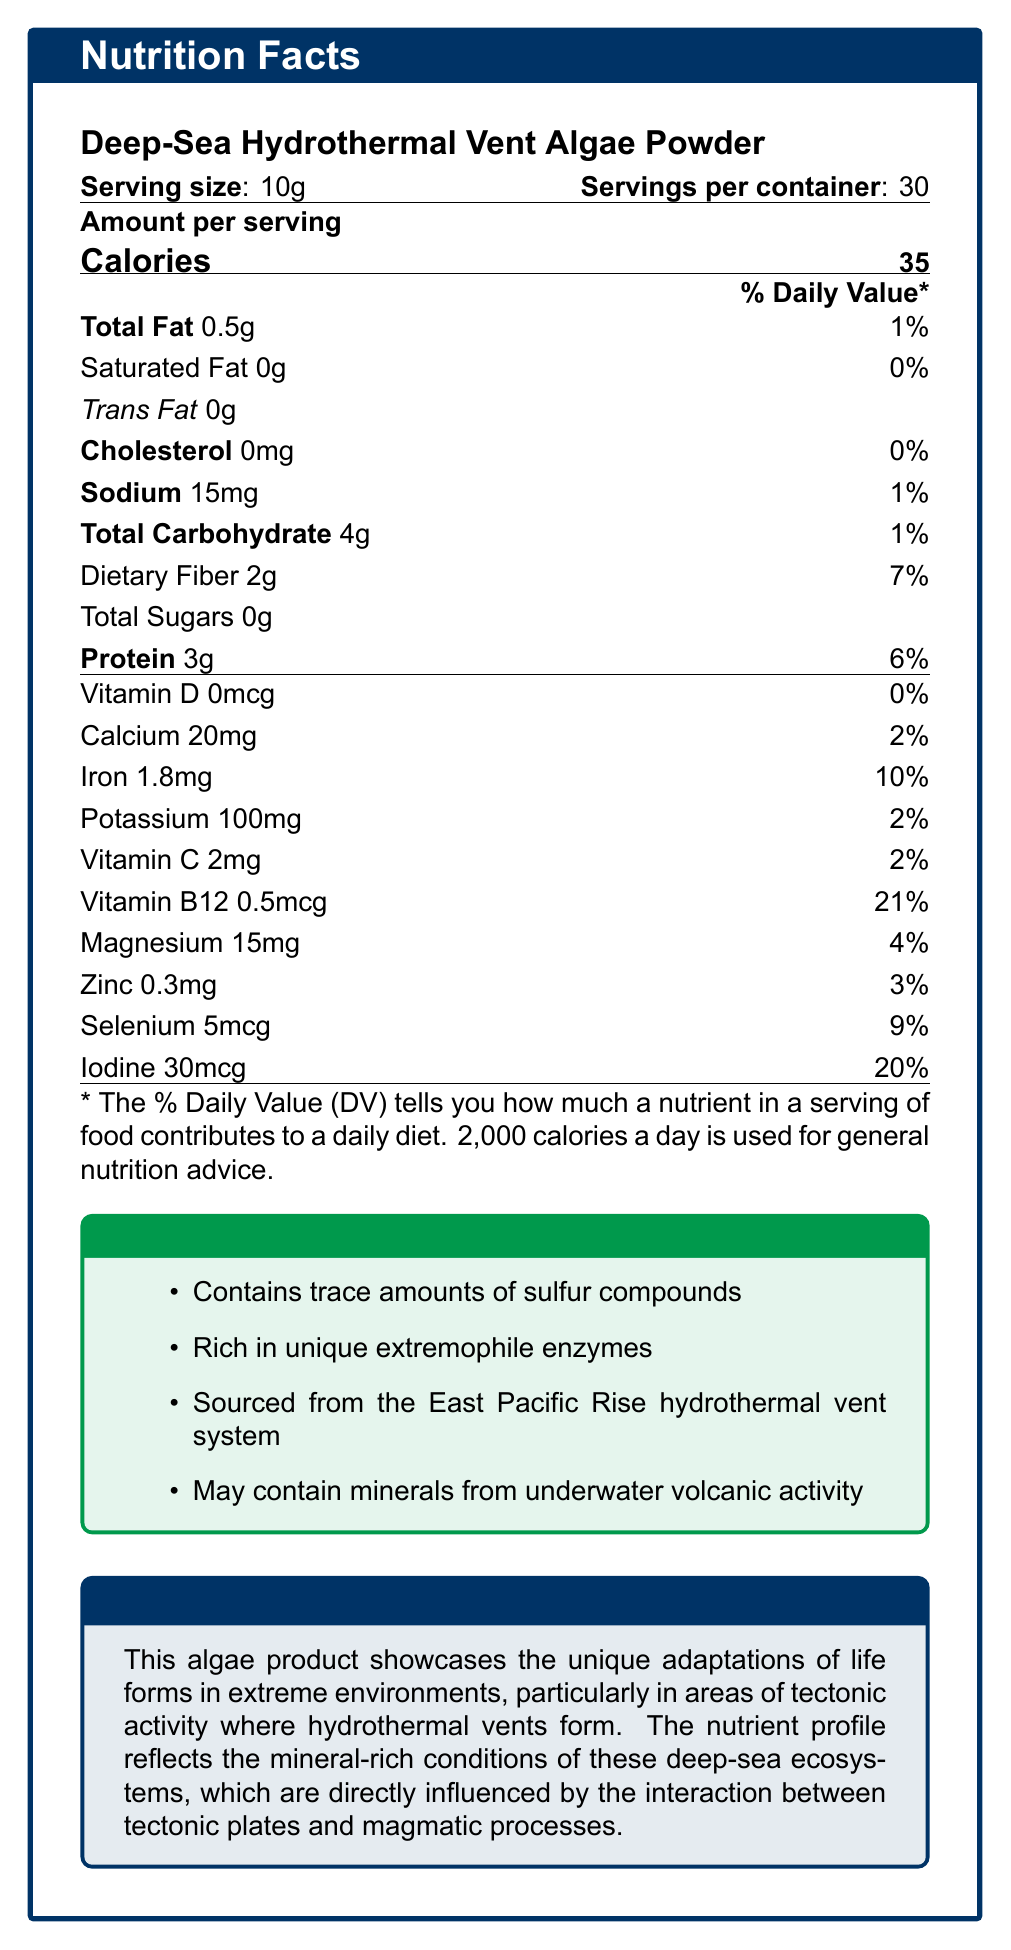what is the serving size? The document lists the serving size as "10g" right under the product name.
Answer: 10g how many calories are in one serving? The document shows that there are 35 calories per serving in the "Amount per serving" section.
Answer: 35 what is the daily value percentage of iron per serving? The document specifies that iron's daily value percentage per serving is 10%.
Answer: 10% which nutrient has the highest daily value percentage per serving? Among all the nutrients listed, Vitamin B12 has the highest daily value percentage at 21%.
Answer: Vitamin B12 what are the total fats included in one serving? The document indicates that the total fat per serving is 0.5g.
Answer: 0.5g what unique features does this algae product contain? These features are listed in the "Additional Information" section of the document.
Answer: Contains trace amounts of sulfur compounds, Rich in unique extremophile enzymes, Sourced from the East Pacific Rise hydrothermal vent system, May contain minerals from underwater volcanic activity what percentage of daily sodium does one serving provide? The document shows that sodium makes up 1% of the daily value per serving.
Answer: 1% which mineral has a daily value percentage higher than calcium but lower than iodine? A. Iron B. Potassium C. Magnesium D. Zinc Iron has a daily value of 10%, which is higher than calcium’s 2% and lower than iodine’s 20%.
Answer: A. Iron how many grams of dietary fiber does one serving have? A. 1g B. 2g C. 4g D. 7g According to the document, one serving contains 2g of dietary fiber.
Answer: B. 2g does this product contain any cholesterol? The document indicates that the cholesterol amount is 0mg, which means there is no cholesterol.
Answer: No is there any trans fat in the product? The document lists trans fat as 0g, indicating that no trans fat is present.
Answer: No summarize the key nutritional contents and significance of the product. The product's nutrients like protein (3g), iron (10% DV), and iodine (20% DV) are key highlights, with low fat (0.5g) and calories (35). The algae's unique sourcing from tectonic activity areas adds geological significance.
Answer: The Deep-Sea Hydrothermal Vent Algae Powder provides important nutrients like protein, iron, iodine, and Vitamin B12, with low calories and fats. It's unique due to its ingredients sourced from hydrothermal vents that reflect the mineral-rich conditions caused by tectonic activity. how many mcg of selenium are in one serving? The document states that one serving contains 5mcg of selenium.
Answer: 5mcg what is the geological significance of this algae product? According to the document, the algae reflect adaptations to deep-sea ecosystems shaped by tectonic and magmatic interactions, highlighting extremophiles' survival in these conditions.
Answer: It showcases the unique adaptations of life forms in extreme environments influenced by tectonic activity and magmatic processes. what amount of vitamin D is present per serving? The document specifies that the amount of Vitamin D per serving is 0mcg.
Answer: 0mcg where is the algae sourced from? The "Additional Information" section says that the algae are sourced from the East Pacific Rise hydrothermal vent system.
Answer: East Pacific Rise hydrothermal vent system how much potassium does one serving contain and what is its daily value percentage? According to the document, one serving contains 100mg of potassium, which is 2% of the daily value.
Answer: 100mg, 2% what is the amount of protein in one serving and its corresponding daily value percentage? The document indicates one serving contains 3g of protein, making up 6% of the daily value.
Answer: 3g, 6% what is the primary source of the minerals contained in this product? The document mentions that the algae "may contain minerals from underwater volcanic activity" but does not specify a primary source.
Answer: Not enough information 